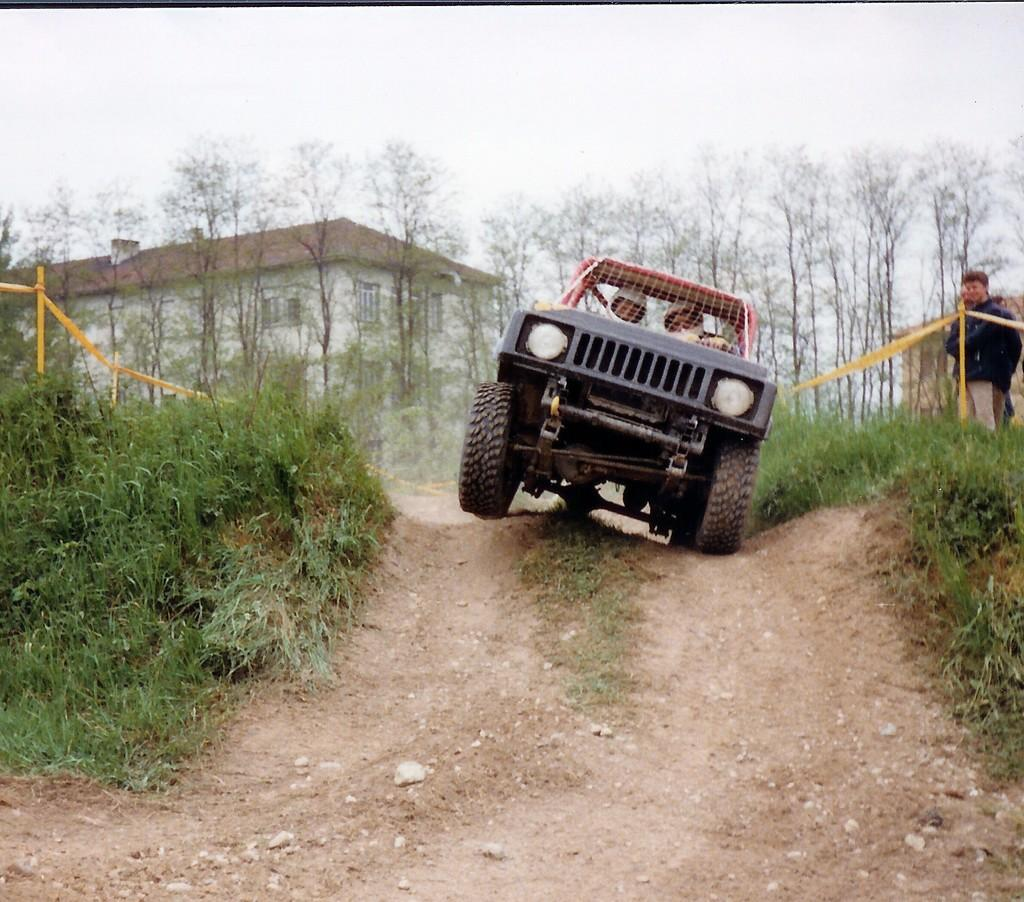What are the people in the image doing? The people in the image are riding a vehicle. Where is the vehicle located? The vehicle is in a hill station. What type of vegetation can be seen in the image? There is grass visible in the image. What can be seen in the background of the image? There is a building in the background of the image. Is there any blood visible on the people riding the vehicle in the image? No, there is no blood visible on the people riding the vehicle in the image. What type of twig can be seen in the image? There is no twig present in the image. 